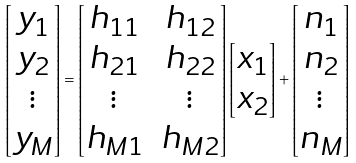Convert formula to latex. <formula><loc_0><loc_0><loc_500><loc_500>\begin{bmatrix} y _ { 1 } \\ y _ { 2 } \\ \vdots \\ y _ { M } \end{bmatrix} = \begin{bmatrix} h _ { 1 1 } & h _ { 1 2 } \\ h _ { 2 1 } & h _ { 2 2 } \\ \vdots & \vdots \\ h _ { M 1 } & h _ { M 2 } \end{bmatrix} \begin{bmatrix} x _ { 1 } \\ x _ { 2 } \end{bmatrix} + \begin{bmatrix} n _ { 1 } \\ n _ { 2 } \\ \vdots \\ n _ { M } \end{bmatrix}</formula> 